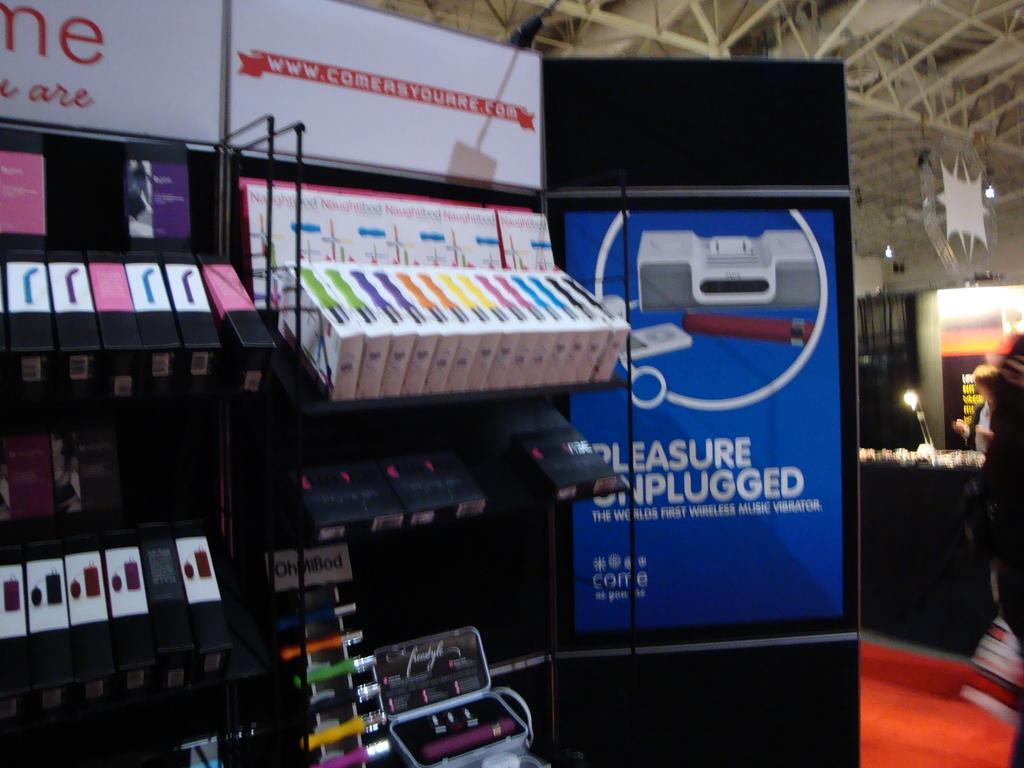Describe this image in one or two sentences. In this image we can see some text on the white boards, some rods attached to the ceiling, three lights, some objects on the stands, some objects attached to the ceiling, some objects on the floor, red carpet on the floor, one board with text, one person truncated on the right side of the image, one object on the right side of the image, one person standing and holding one object. 